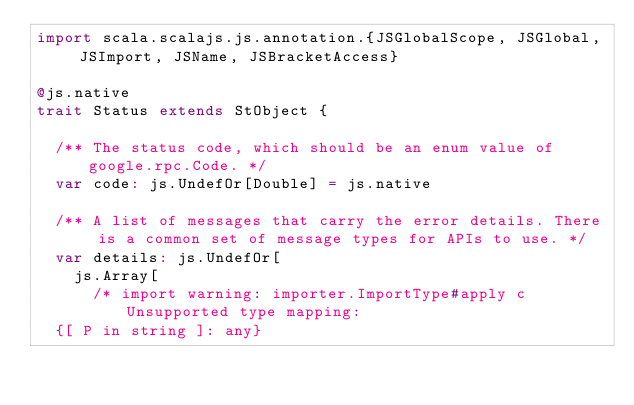Convert code to text. <code><loc_0><loc_0><loc_500><loc_500><_Scala_>import scala.scalajs.js.annotation.{JSGlobalScope, JSGlobal, JSImport, JSName, JSBracketAccess}

@js.native
trait Status extends StObject {
  
  /** The status code, which should be an enum value of google.rpc.Code. */
  var code: js.UndefOr[Double] = js.native
  
  /** A list of messages that carry the error details. There is a common set of message types for APIs to use. */
  var details: js.UndefOr[
    js.Array[
      /* import warning: importer.ImportType#apply c Unsupported type mapping: 
  {[ P in string ]: any}</code> 